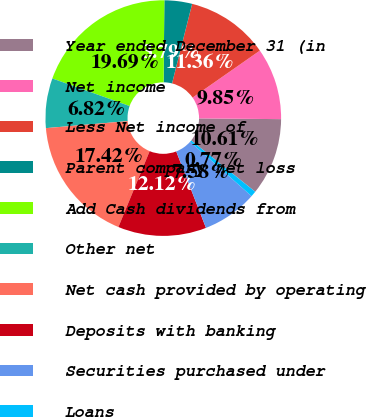Convert chart. <chart><loc_0><loc_0><loc_500><loc_500><pie_chart><fcel>Year ended December 31 (in<fcel>Net income<fcel>Less Net income of<fcel>Parent company net loss<fcel>Add Cash dividends from<fcel>Other net<fcel>Net cash provided by operating<fcel>Deposits with banking<fcel>Securities purchased under<fcel>Loans<nl><fcel>10.61%<fcel>9.85%<fcel>11.36%<fcel>3.79%<fcel>19.69%<fcel>6.82%<fcel>17.42%<fcel>12.12%<fcel>7.58%<fcel>0.77%<nl></chart> 